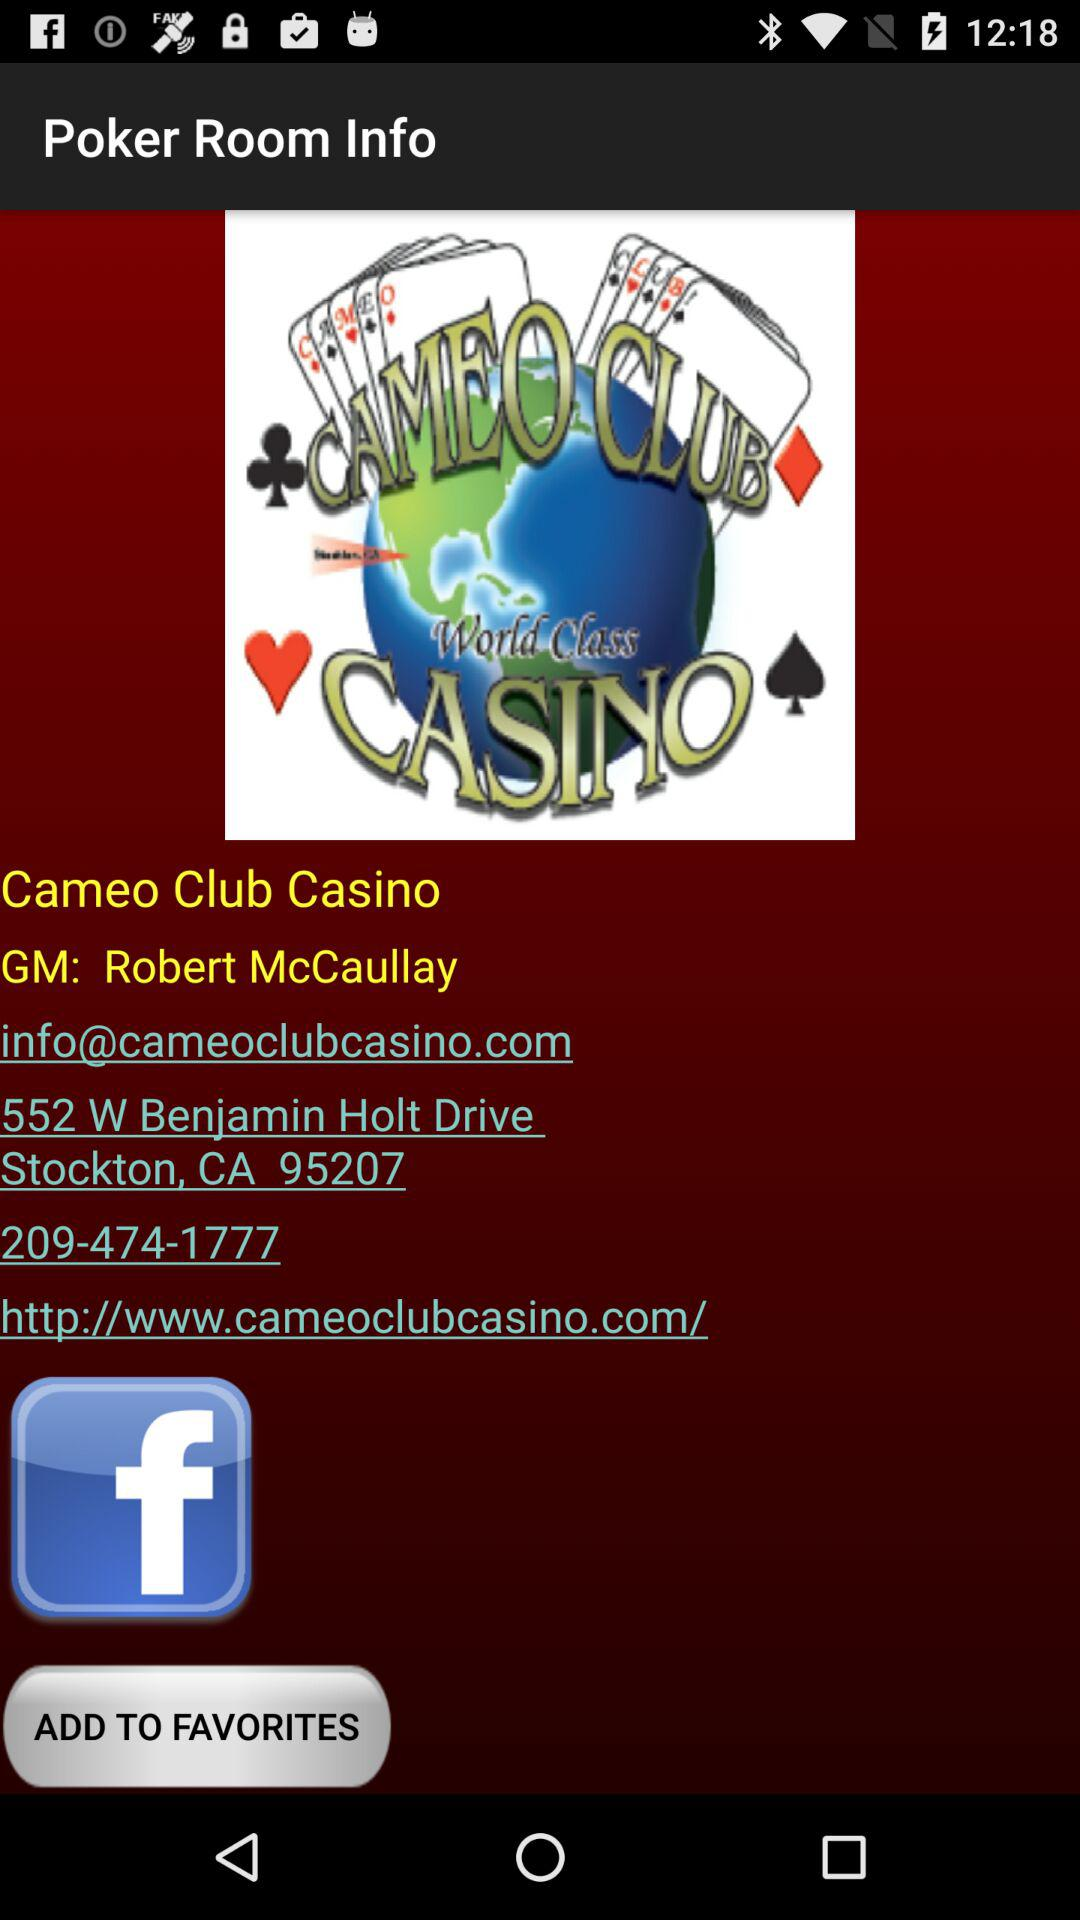What is the website of the Cameo club casino? The website is info@cameoclubcasino.com. 